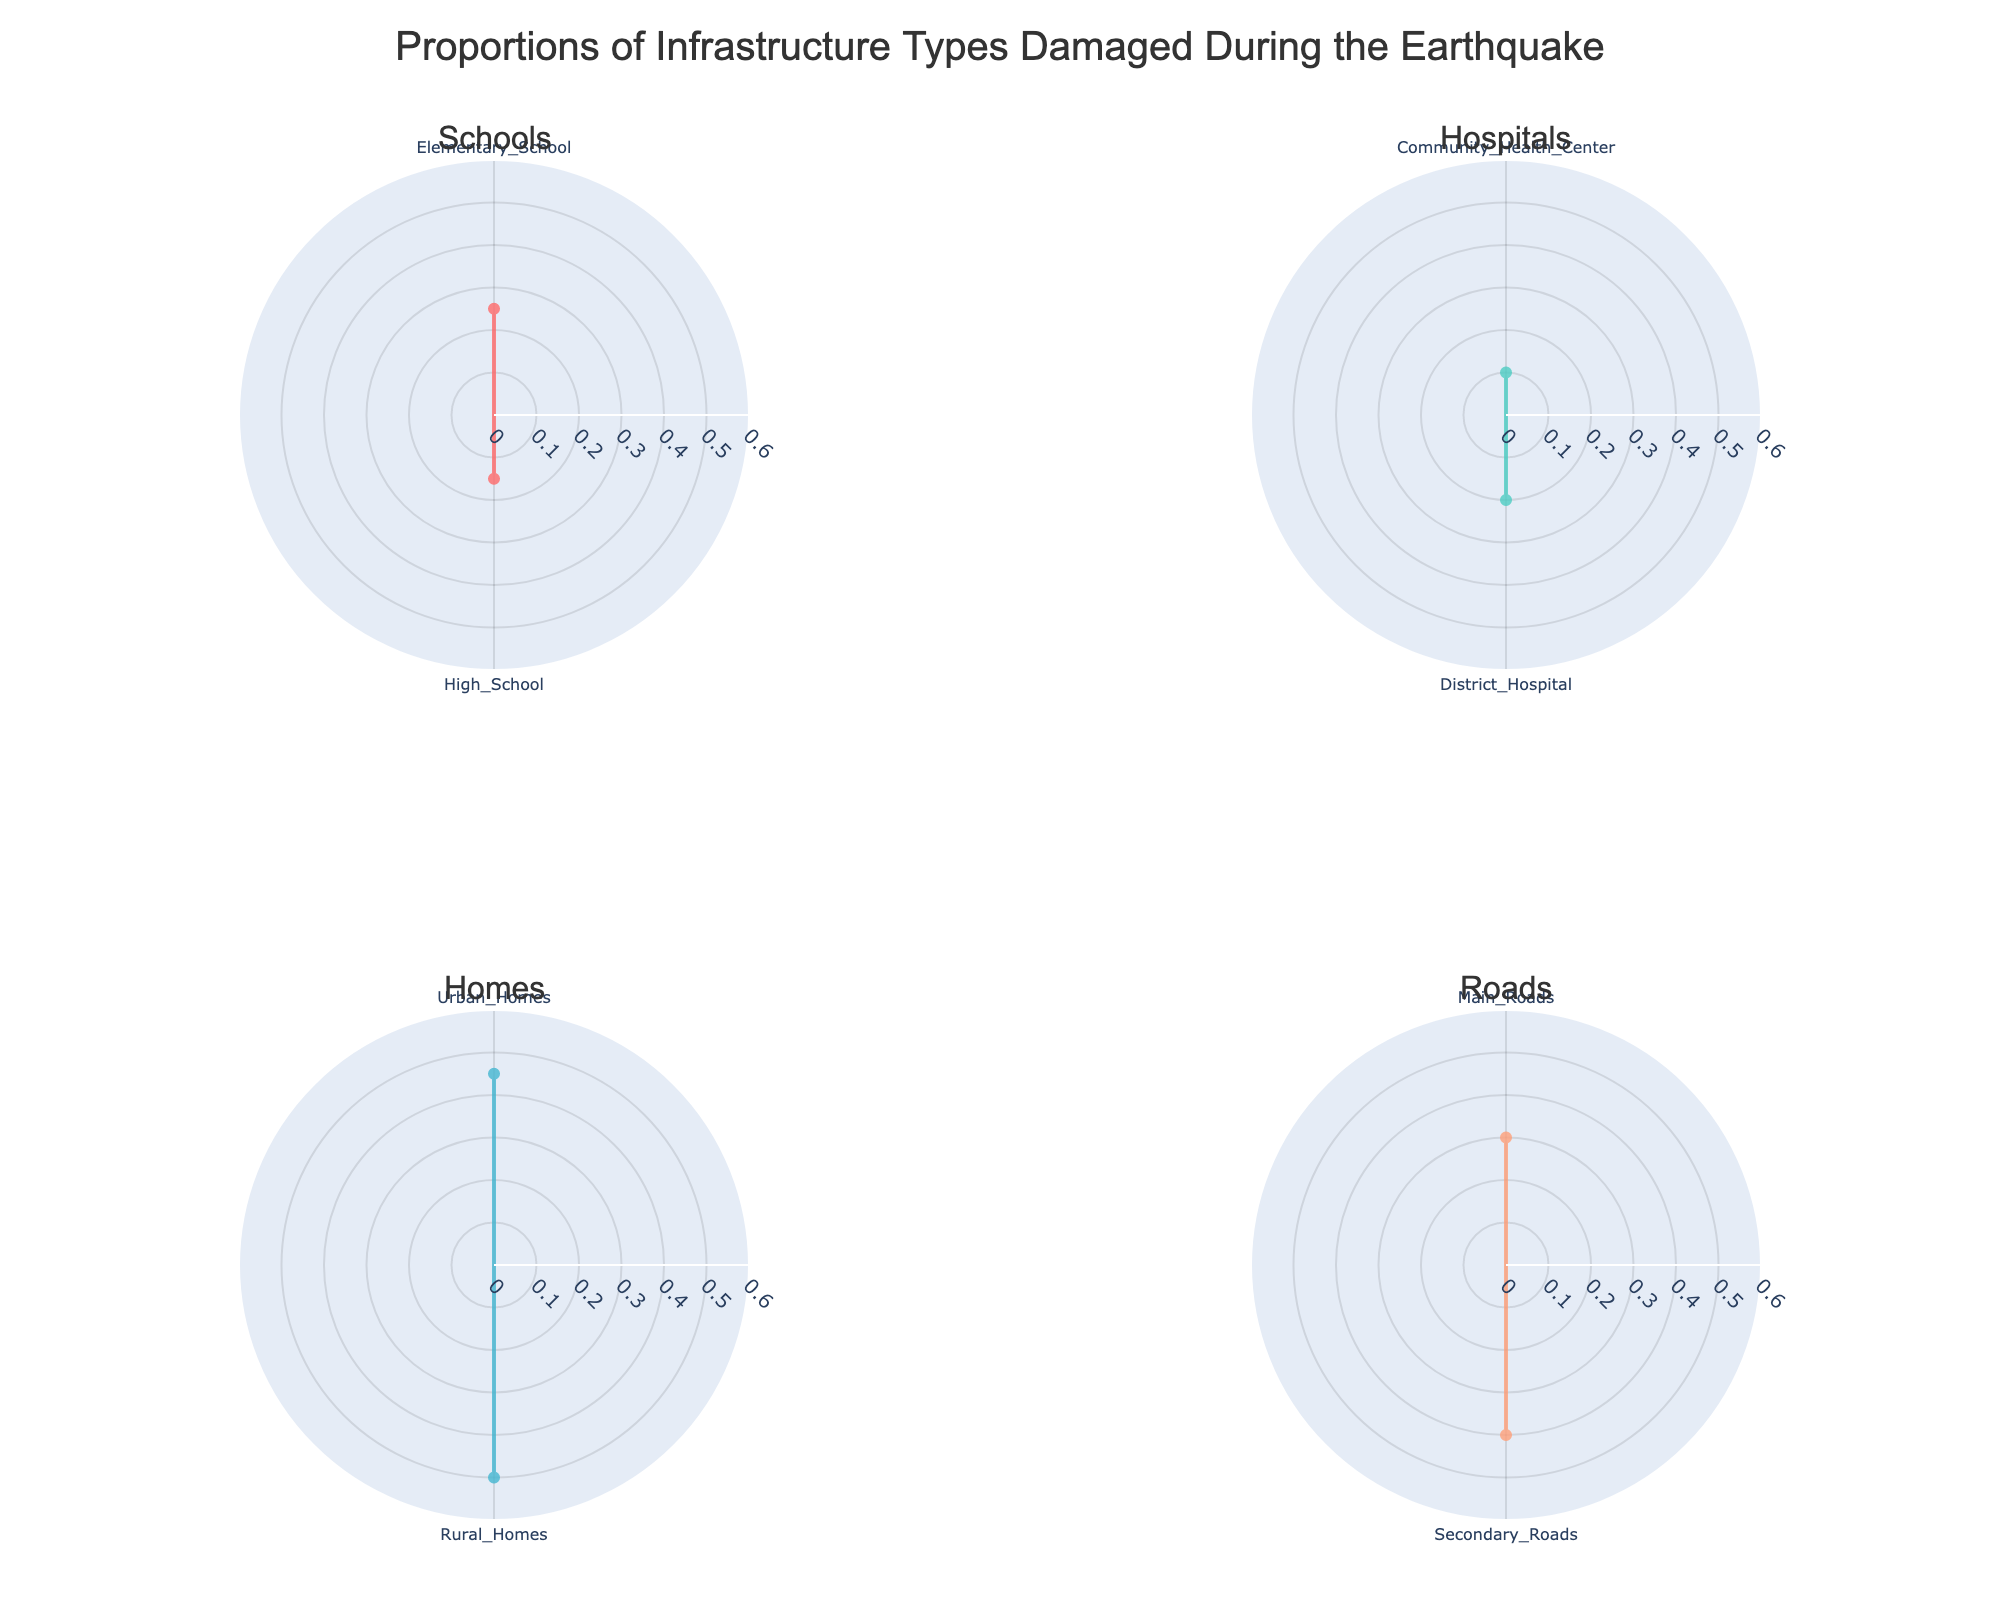What is the title shown on the figure? At the top of the figure, there is a title which provides a summary of what the figure represents. The title is "Proportions of Infrastructure Types Damaged During the Earthquake."
Answer: Proportions of Infrastructure Types Damaged During the Earthquake Which subplot shows the damage to Schools? The subplots are titled according to the categories of infrastructure damaged. The Schools subplot is one of the four titles.
Answer: Schools What proportion of district hospitals was damaged? In the Hospitals subplot, there are two types of hospitals: Community Health Center and District Hospital. The proportion for District Hospital is 0.2, or 20%.
Answer: 20% Which category has the highest proportion of damage and what is the proportion? Looking at the four subplots, the highest proportion of damage is in the Homes category, specifically Rural Homes with a proportion of 0.5, or 50%.
Answer: Homes with 50% Based on the subplots, were urban homes or rural homes more affected by the earthquake? In the Homes subplot, the proportions are shown for Urban Homes and Rural Homes. Urban Homes have a proportion of 0.45 and Rural Homes have a proportion of 0.5. Hence, Rural Homes were more affected.
Answer: Rural Homes were more affected How does the damage proportion of elementary schools compare to high schools? In the Schools subplot, Elementary Schools have a proportion of 0.25 while High Schools have 0.15. Elementary Schools have a higher proportion than High Schools.
Answer: Elementary Schools have a higher proportion What is the total proportion of all types of roads damaged? In the Roads subplot, the proportions for Main Roads and Secondary Roads are 0.3 and 0.4, respectively. Adding them together gives a total of 0.7, or 70%.
Answer: 70% If you add the proportion of damage for Community Health Centers and District Hospitals, what do you get? In the Hospitals subplot, the proportions are 0.1 for Community Health Centers and 0.2 for District Hospitals. Summing these gives 0.3, or 30%.
Answer: 30% Which type of infrastructure has the most number of data points plotted? Counting the number of types shown in each subplot, Homes have the most data points with two types: Urban Homes and Rural Homes.
Answer: Homes How does the proportion of damaged elementary schools compare to secondary roads? Elementary Schools in the Schools subplot have a proportion of 0.25, and Secondary Roads in the Roads subplot have a proportion of 0.4. Secondary Roads have a higher proportion of damage.
Answer: Secondary Roads have a higher proportion 